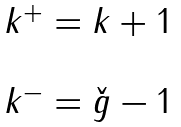<formula> <loc_0><loc_0><loc_500><loc_500>\begin{array} { l } { { k ^ { + } = k + 1 } } \\ { \ } \\ { { k ^ { - } = \check { g } - 1 } } \end{array}</formula> 